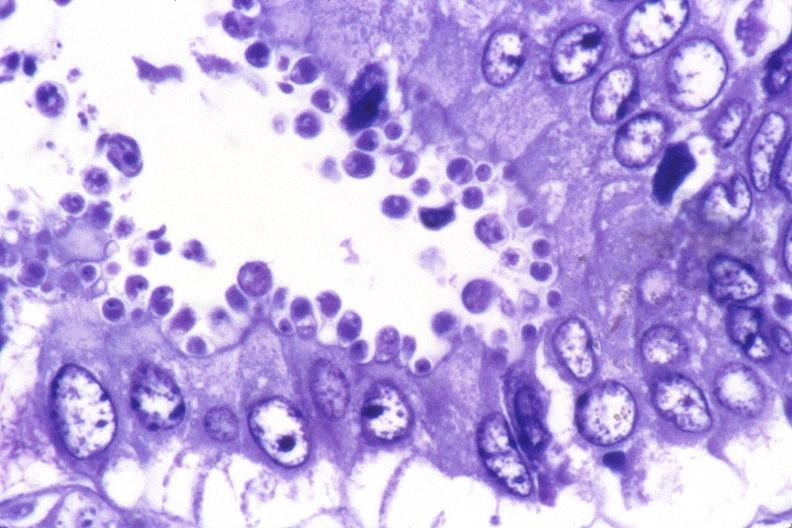s gastrointestinal present?
Answer the question using a single word or phrase. Yes 